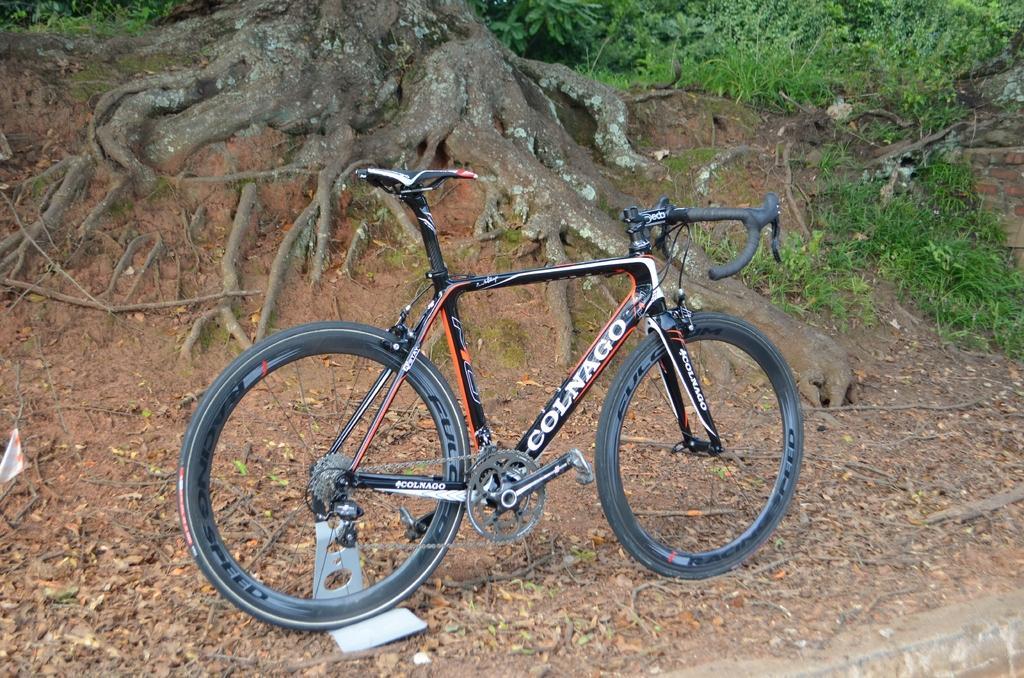In one or two sentences, can you explain what this image depicts? In this picture I can see a bicycle, there are plants, grass, and in the background there are roots of a tree. 